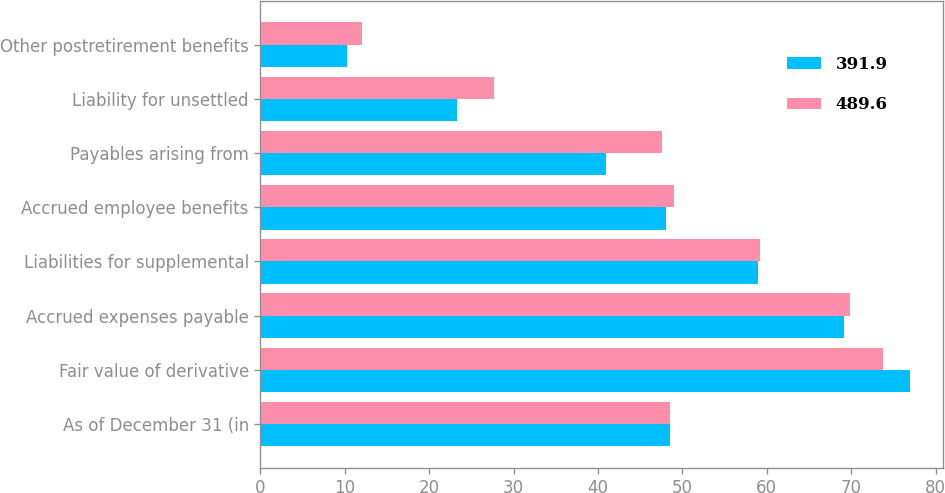<chart> <loc_0><loc_0><loc_500><loc_500><stacked_bar_chart><ecel><fcel>As of December 31 (in<fcel>Fair value of derivative<fcel>Accrued expenses payable<fcel>Liabilities for supplemental<fcel>Accrued employee benefits<fcel>Payables arising from<fcel>Liability for unsettled<fcel>Other postretirement benefits<nl><fcel>391.9<fcel>48.55<fcel>77<fcel>69.1<fcel>59<fcel>48.1<fcel>40.9<fcel>23.3<fcel>10.3<nl><fcel>489.6<fcel>48.55<fcel>73.8<fcel>69.9<fcel>59.2<fcel>49<fcel>47.6<fcel>27.7<fcel>12<nl></chart> 